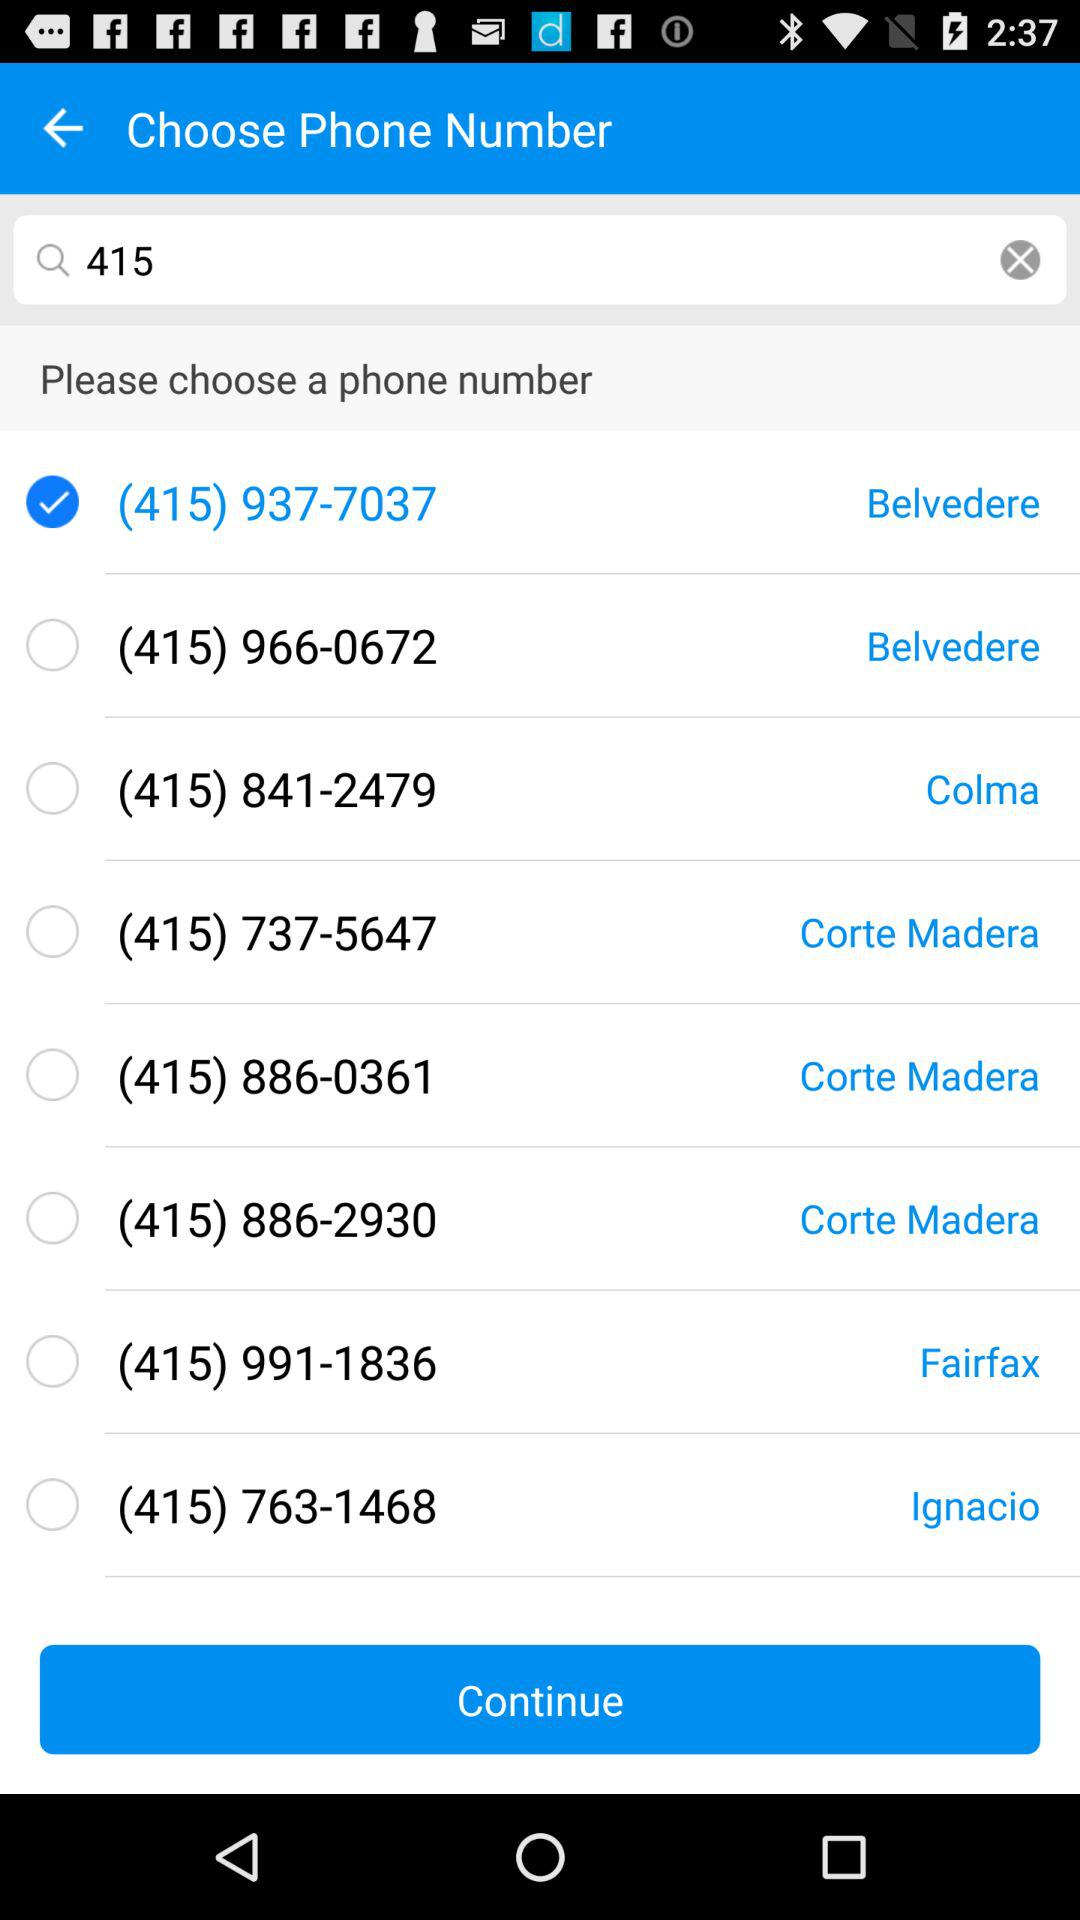What is the selected phone number? The selected phone number is (415) 937-7037. 